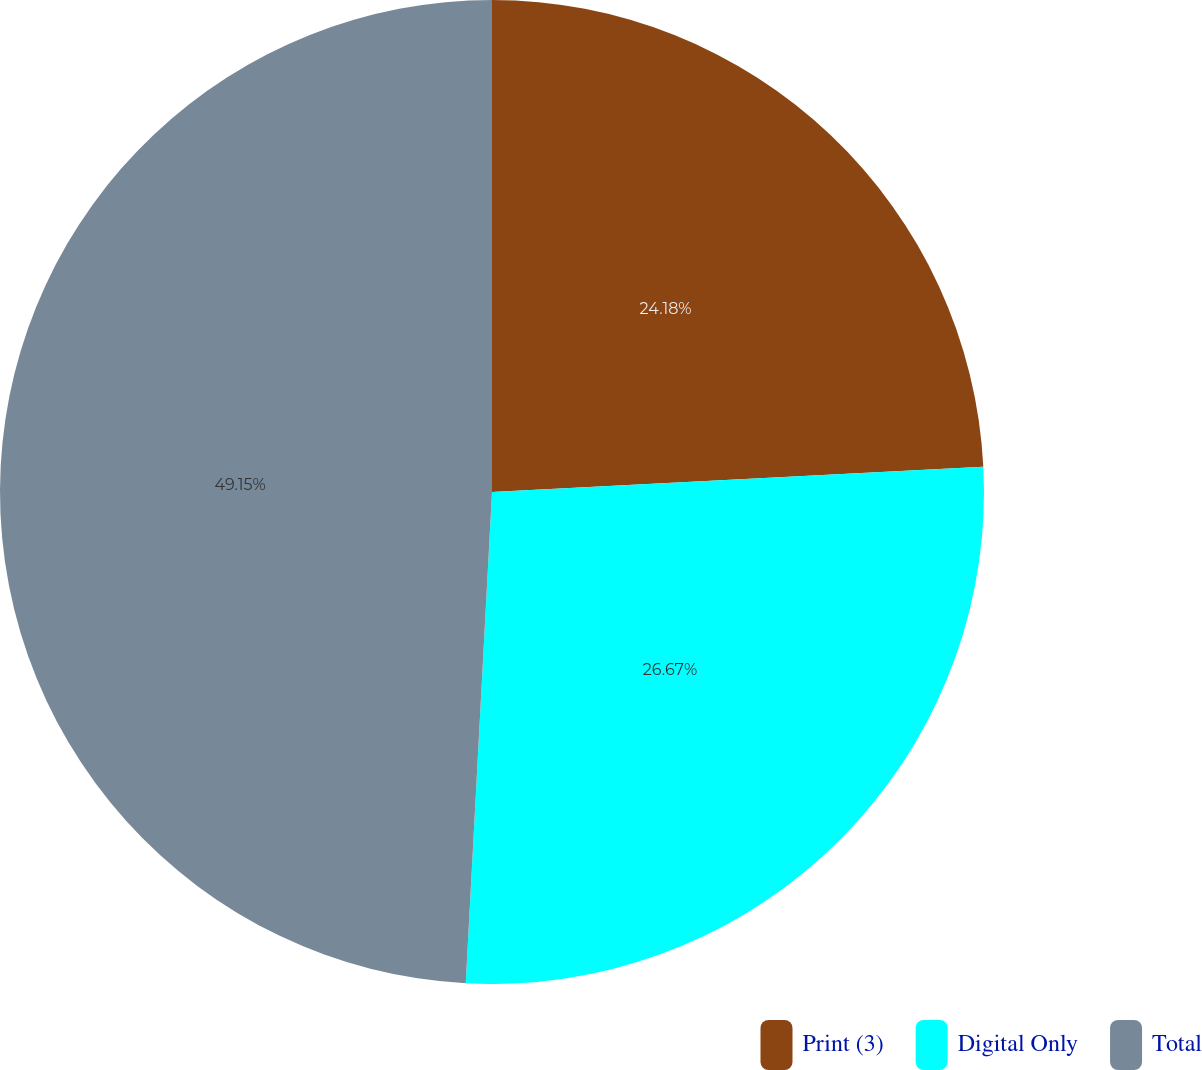<chart> <loc_0><loc_0><loc_500><loc_500><pie_chart><fcel>Print (3)<fcel>Digital Only<fcel>Total<nl><fcel>24.18%<fcel>26.67%<fcel>49.15%<nl></chart> 